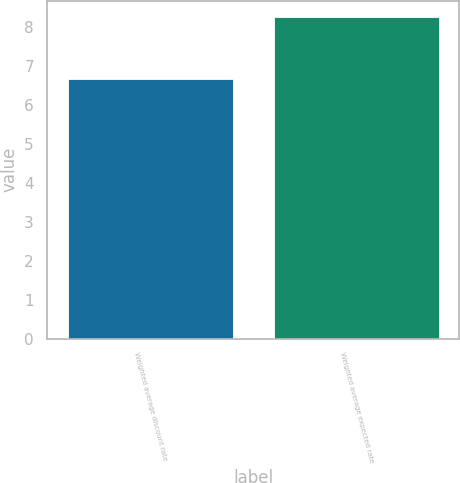<chart> <loc_0><loc_0><loc_500><loc_500><bar_chart><fcel>Weighted average discount rate<fcel>Weighted average expected rate<nl><fcel>6.65<fcel>8.25<nl></chart> 